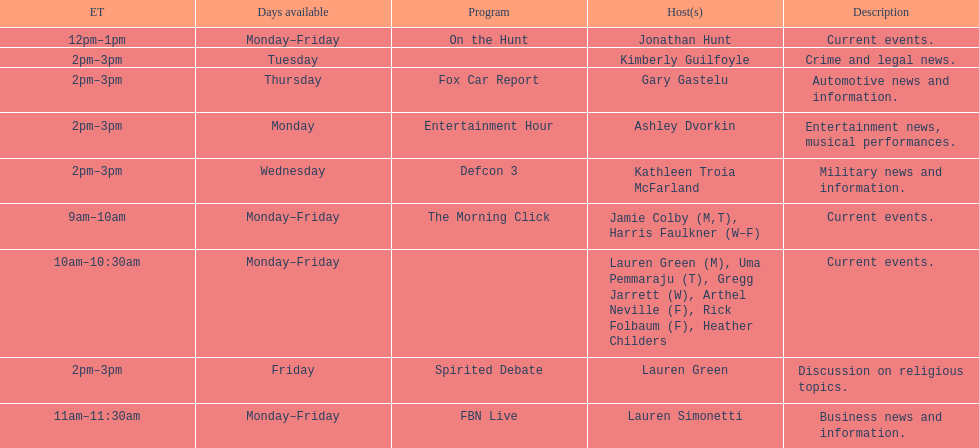How long does the show defcon 3 last? 1 hour. 